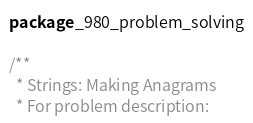<code> <loc_0><loc_0><loc_500><loc_500><_Scala_>package _980_problem_solving

/**
  * Strings: Making Anagrams
  * For problem description:</code> 